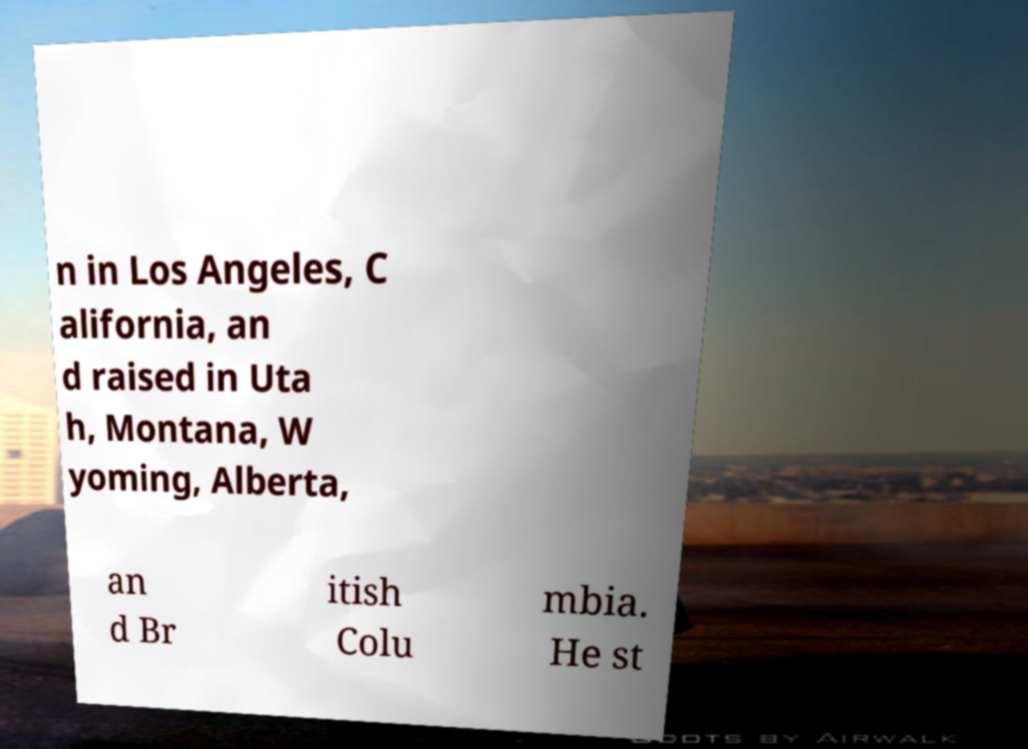Please read and relay the text visible in this image. What does it say? n in Los Angeles, C alifornia, an d raised in Uta h, Montana, W yoming, Alberta, an d Br itish Colu mbia. He st 